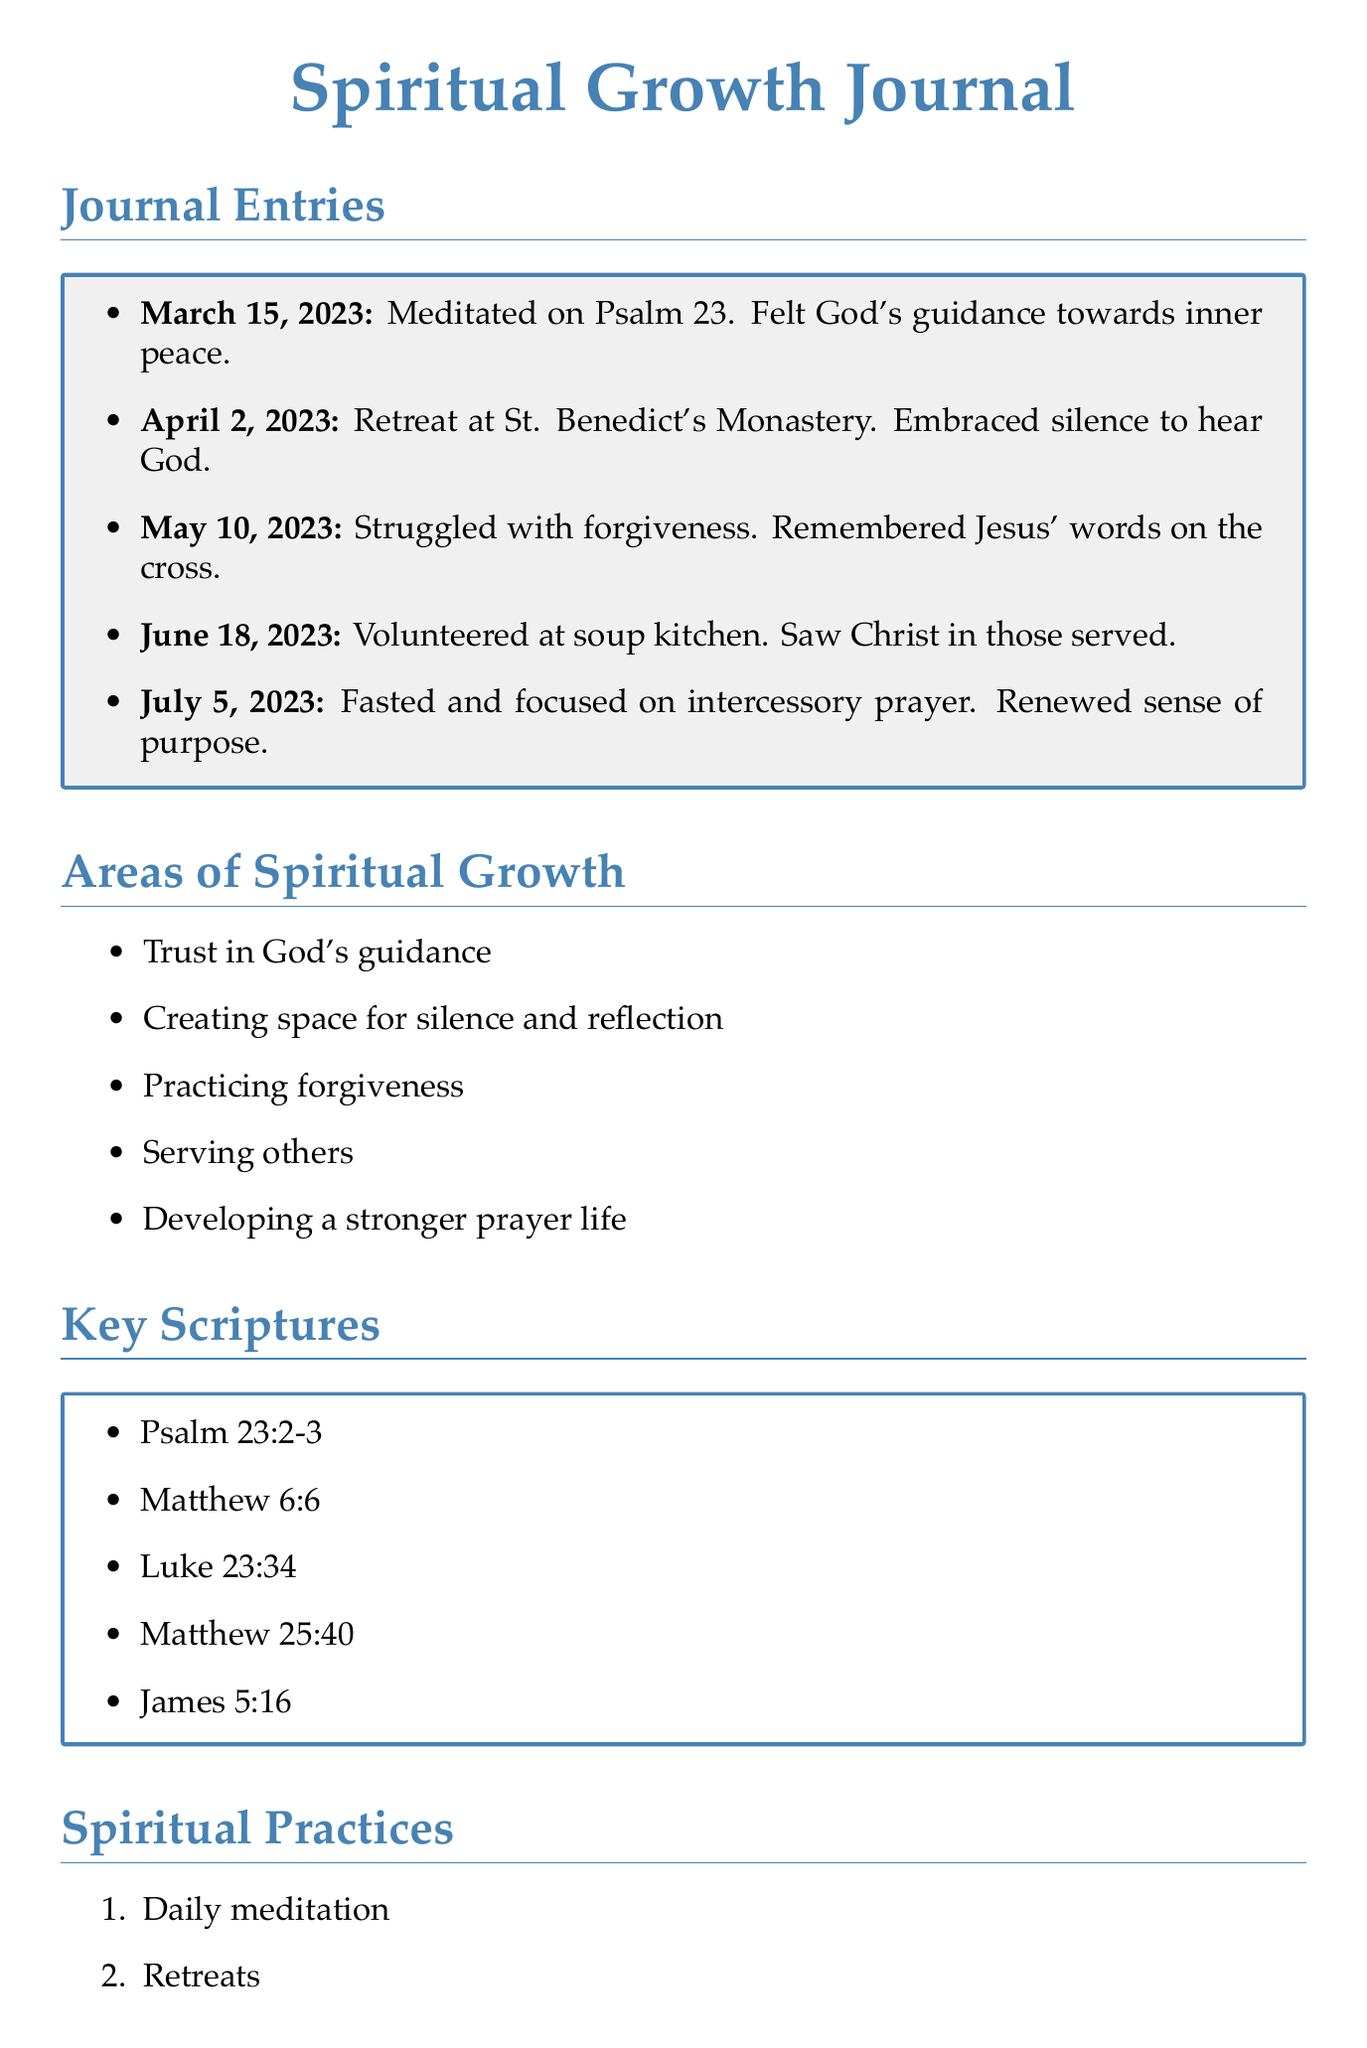What date did the entry reflecting on Psalm 23 occur? The date mentioned for the reflection on Psalm 23 is March 15, 2023.
Answer: March 15, 2023 What phrase from Psalm 23 resonated deeply? The phrase that resonated deeply was "He leads me beside quiet waters."
Answer: He leads me beside quiet waters What was the main growth area for the entry on April 2, 2023? The growth area for the April 2 entry was "Creating space for silence and reflection."
Answer: Creating space for silence and reflection Which scripture is referenced in the entry about volunteering? The entry about volunteering references Matthew 25:40.
Answer: Matthew 25:40 How many journal entries are documented in total? There are five journal entries documented in the document.
Answer: 5 What spiritual practice was emphasized on July 5, 2023? The emphasized spiritual practice on July 5, 2023 was "Fasting and intercessory prayer."
Answer: Fasting and intercessory prayer What key scripture is mentioned alongside forgiveness exercises? James 5:16 is mentioned alongside forgiveness exercises.
Answer: James 5:16 What type of spiritual practice involves community service? "Community service" is listed as one of the spiritual practices in the document.
Answer: Community service What is the ending quote included in the document? The ending quote included in the document is "The journey of a thousand miles begins with one step."
Answer: The journey of a thousand miles begins with one step 